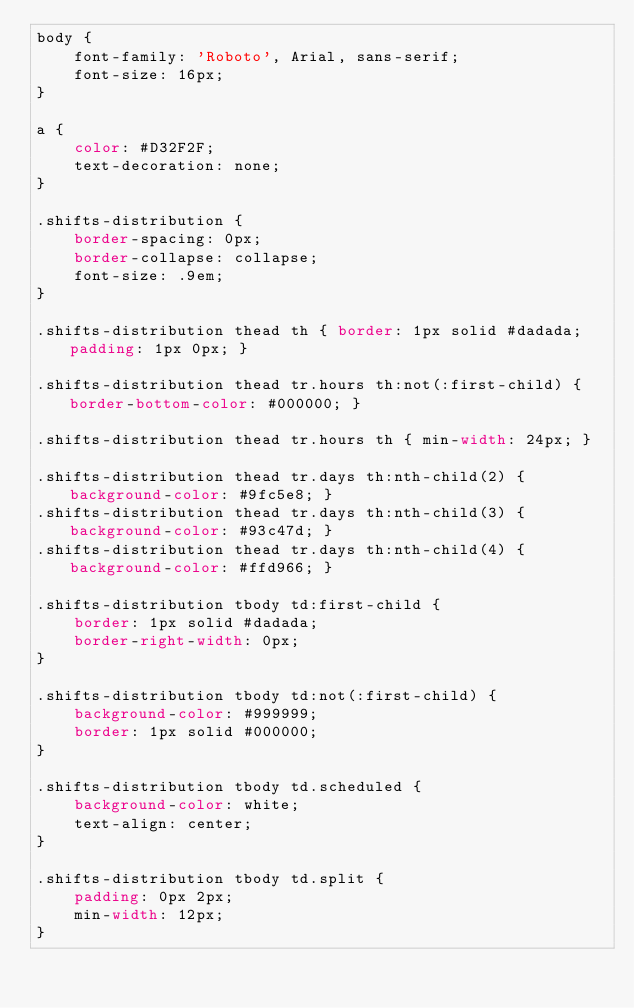Convert code to text. <code><loc_0><loc_0><loc_500><loc_500><_CSS_>body {
    font-family: 'Roboto', Arial, sans-serif;
    font-size: 16px;
}

a {
    color: #D32F2F;
    text-decoration: none;
}

.shifts-distribution {
    border-spacing: 0px;
    border-collapse: collapse;
    font-size: .9em;
}

.shifts-distribution thead th { border: 1px solid #dadada; padding: 1px 0px; }

.shifts-distribution thead tr.hours th:not(:first-child) { border-bottom-color: #000000; }

.shifts-distribution thead tr.hours th { min-width: 24px; }

.shifts-distribution thead tr.days th:nth-child(2) { background-color: #9fc5e8; }
.shifts-distribution thead tr.days th:nth-child(3) { background-color: #93c47d; }
.shifts-distribution thead tr.days th:nth-child(4) { background-color: #ffd966; }

.shifts-distribution tbody td:first-child {
    border: 1px solid #dadada;
    border-right-width: 0px;
}

.shifts-distribution tbody td:not(:first-child) {
    background-color: #999999;
    border: 1px solid #000000;
}

.shifts-distribution tbody td.scheduled {
    background-color: white;
    text-align: center;
}

.shifts-distribution tbody td.split {
    padding: 0px 2px;
    min-width: 12px;
}
</code> 